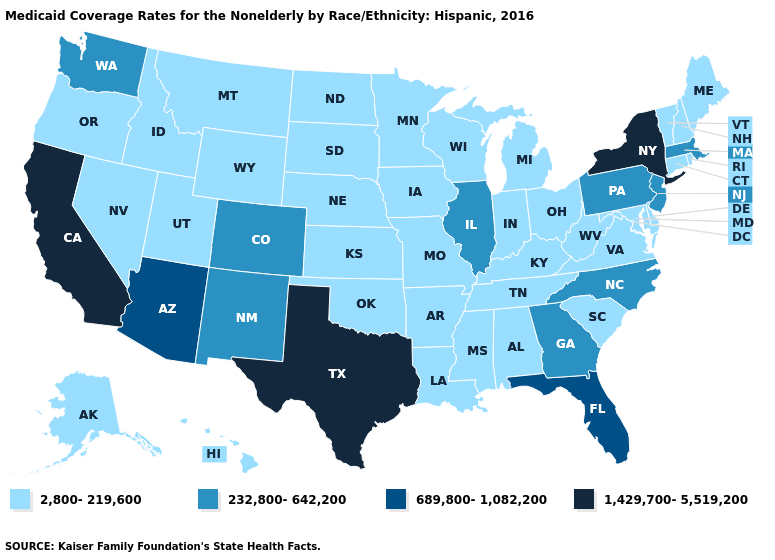What is the lowest value in the MidWest?
Be succinct. 2,800-219,600. What is the value of West Virginia?
Short answer required. 2,800-219,600. What is the value of Oklahoma?
Short answer required. 2,800-219,600. Does California have the highest value in the USA?
Keep it brief. Yes. Does Texas have the highest value in the South?
Short answer required. Yes. What is the lowest value in states that border Colorado?
Answer briefly. 2,800-219,600. What is the value of Montana?
Keep it brief. 2,800-219,600. Which states hav the highest value in the West?
Keep it brief. California. Does Nevada have the highest value in the West?
Short answer required. No. What is the lowest value in the South?
Quick response, please. 2,800-219,600. Which states have the lowest value in the USA?
Answer briefly. Alabama, Alaska, Arkansas, Connecticut, Delaware, Hawaii, Idaho, Indiana, Iowa, Kansas, Kentucky, Louisiana, Maine, Maryland, Michigan, Minnesota, Mississippi, Missouri, Montana, Nebraska, Nevada, New Hampshire, North Dakota, Ohio, Oklahoma, Oregon, Rhode Island, South Carolina, South Dakota, Tennessee, Utah, Vermont, Virginia, West Virginia, Wisconsin, Wyoming. What is the value of Pennsylvania?
Short answer required. 232,800-642,200. Name the states that have a value in the range 689,800-1,082,200?
Write a very short answer. Arizona, Florida. What is the lowest value in states that border Missouri?
Give a very brief answer. 2,800-219,600. Is the legend a continuous bar?
Concise answer only. No. 